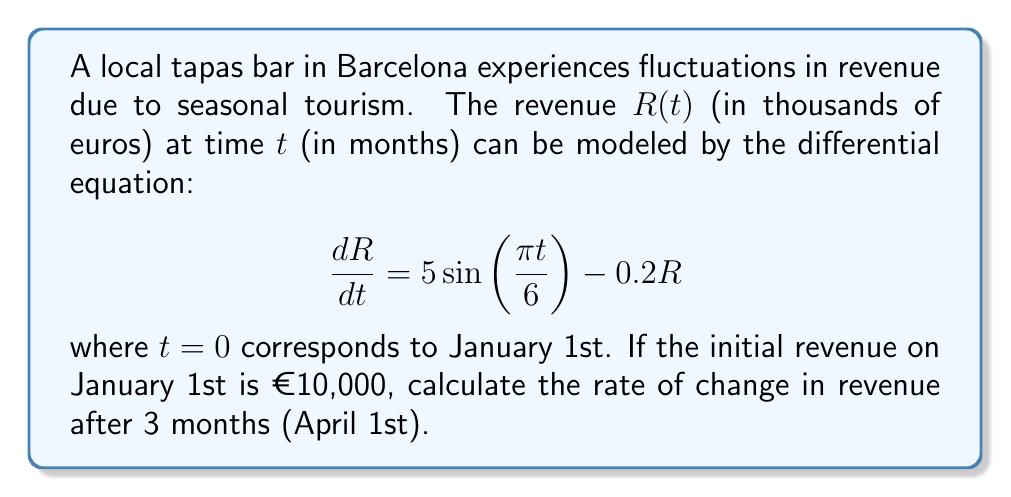Provide a solution to this math problem. To solve this problem, we need to follow these steps:

1) First, we need to find the general solution to the differential equation. The equation is of the form:

   $$\frac{dR}{dt} + 0.2R = 5\sin\left(\frac{\pi t}{6}\right)$$

   This is a first-order linear differential equation.

2) The general solution to this equation is:

   $$R(t) = e^{-0.2t}\left(C + \int 5e^{0.2t}\sin\left(\frac{\pi t}{6}\right)dt\right)$$

   where $C$ is a constant of integration.

3) After integrating and simplifying, we get:

   $$R(t) = Ae^{-0.2t} + 3\sin\left(\frac{\pi t}{6}\right) - 4\cos\left(\frac{\pi t}{6}\right)$$

   where $A$ is a new constant.

4) Using the initial condition $R(0) = 10$, we can find $A$:

   $$10 = A - 4$$
   $$A = 14$$

5) So, the particular solution is:

   $$R(t) = 14e^{-0.2t} + 3\sin\left(\frac{\pi t}{6}\right) - 4\cos\left(\frac{\pi t}{6}\right)$$

6) To find the rate of change after 3 months, we need to differentiate this equation and evaluate at $t=3$:

   $$\frac{dR}{dt} = -2.8e^{-0.2t} + 0.5\pi\cos\left(\frac{\pi t}{6}\right) + \frac{2\pi}{3}\sin\left(\frac{\pi t}{6}\right)$$

7) Evaluating at $t=3$:

   $$\frac{dR}{dt}(3) = -2.8e^{-0.6} + 0.5\pi\cos\left(\frac{\pi}{2}\right) + \frac{2\pi}{3}\sin\left(\frac{\pi}{2}\right)$$

8) Simplifying:

   $$\frac{dR}{dt}(3) = -2.8e^{-0.6} + \frac{2\pi}{3} \approx 0.7041$$
Answer: The rate of change in revenue after 3 months (April 1st) is approximately 704.1 euros per month. 